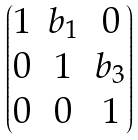Convert formula to latex. <formula><loc_0><loc_0><loc_500><loc_500>\begin{pmatrix} 1 & b _ { 1 } & 0 \\ 0 & 1 & b _ { 3 } \\ 0 & 0 & 1 \end{pmatrix}</formula> 